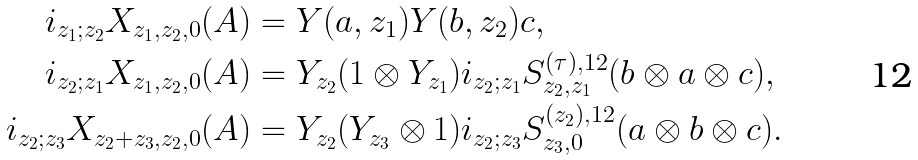Convert formula to latex. <formula><loc_0><loc_0><loc_500><loc_500>i _ { z _ { 1 } ; z _ { 2 } } X _ { z _ { 1 } , z _ { 2 } , 0 } ( A ) & = Y ( a , z _ { 1 } ) Y ( b , z _ { 2 } ) c , \\ i _ { z _ { 2 } ; z _ { 1 } } X _ { z _ { 1 } , z _ { 2 } , 0 } ( A ) & = Y _ { z _ { 2 } } ( 1 \otimes Y _ { z _ { 1 } } ) i _ { z _ { 2 } ; z _ { 1 } } S ^ { ( \tau ) , 1 2 } _ { z _ { 2 } , z _ { 1 } } ( b \otimes a \otimes c ) , \\ i _ { z _ { 2 } ; z _ { 3 } } X _ { z _ { 2 } + z _ { 3 } , z _ { 2 } , 0 } ( A ) & = Y _ { z _ { 2 } } ( Y _ { z _ { 3 } } \otimes 1 ) i _ { z _ { 2 } ; z _ { 3 } } S ^ { ( z _ { 2 } ) , 1 2 } _ { z _ { 3 } , 0 } ( a \otimes b \otimes c ) .</formula> 